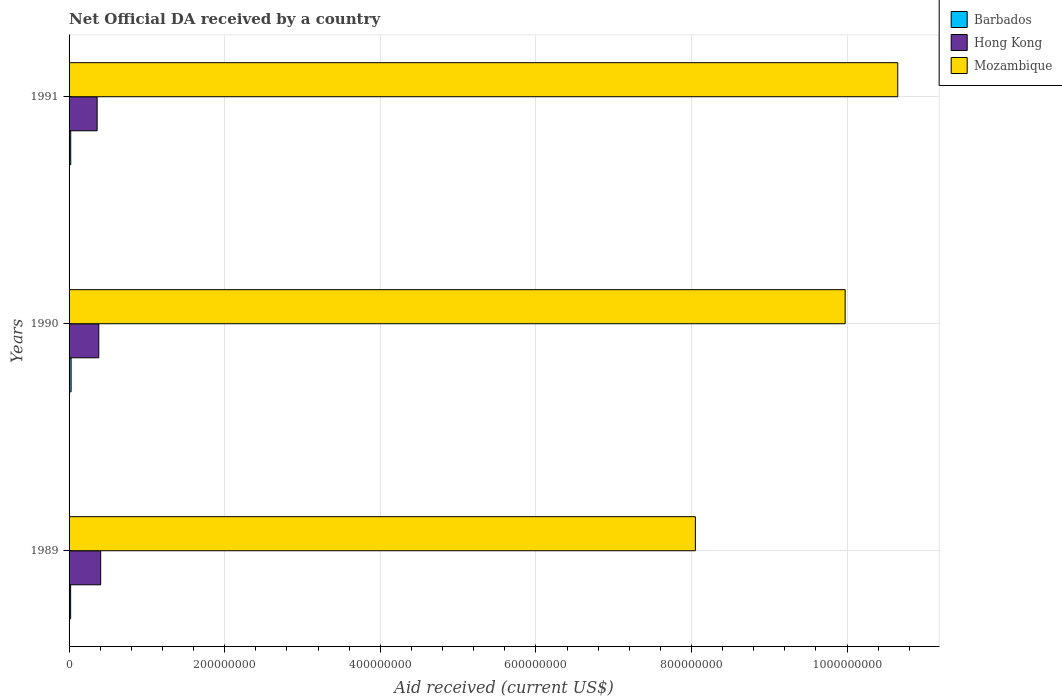Are the number of bars per tick equal to the number of legend labels?
Give a very brief answer. Yes. Are the number of bars on each tick of the Y-axis equal?
Offer a terse response. Yes. How many bars are there on the 1st tick from the top?
Your answer should be compact. 3. In how many cases, is the number of bars for a given year not equal to the number of legend labels?
Ensure brevity in your answer.  0. What is the net official development assistance aid received in Barbados in 1991?
Offer a terse response. 2.12e+06. Across all years, what is the maximum net official development assistance aid received in Mozambique?
Provide a succinct answer. 1.07e+09. Across all years, what is the minimum net official development assistance aid received in Barbados?
Ensure brevity in your answer.  2.01e+06. In which year was the net official development assistance aid received in Mozambique maximum?
Provide a succinct answer. 1991. In which year was the net official development assistance aid received in Hong Kong minimum?
Make the answer very short. 1991. What is the total net official development assistance aid received in Hong Kong in the graph?
Keep it short and to the point. 1.15e+08. What is the difference between the net official development assistance aid received in Mozambique in 1989 and that in 1990?
Your answer should be very brief. -1.93e+08. What is the difference between the net official development assistance aid received in Hong Kong in 1990 and the net official development assistance aid received in Barbados in 1989?
Provide a short and direct response. 3.62e+07. What is the average net official development assistance aid received in Mozambique per year?
Your response must be concise. 9.56e+08. In the year 1991, what is the difference between the net official development assistance aid received in Barbados and net official development assistance aid received in Mozambique?
Make the answer very short. -1.06e+09. In how many years, is the net official development assistance aid received in Mozambique greater than 640000000 US$?
Your answer should be very brief. 3. What is the ratio of the net official development assistance aid received in Barbados in 1989 to that in 1991?
Offer a very short reply. 0.95. Is the net official development assistance aid received in Barbados in 1989 less than that in 1990?
Offer a terse response. Yes. Is the difference between the net official development assistance aid received in Barbados in 1989 and 1990 greater than the difference between the net official development assistance aid received in Mozambique in 1989 and 1990?
Provide a succinct answer. Yes. What is the difference between the highest and the second highest net official development assistance aid received in Barbados?
Offer a very short reply. 5.10e+05. What is the difference between the highest and the lowest net official development assistance aid received in Hong Kong?
Your answer should be compact. 4.55e+06. Is the sum of the net official development assistance aid received in Barbados in 1990 and 1991 greater than the maximum net official development assistance aid received in Hong Kong across all years?
Your answer should be very brief. No. What does the 3rd bar from the top in 1989 represents?
Ensure brevity in your answer.  Barbados. What does the 1st bar from the bottom in 1991 represents?
Provide a short and direct response. Barbados. Is it the case that in every year, the sum of the net official development assistance aid received in Barbados and net official development assistance aid received in Mozambique is greater than the net official development assistance aid received in Hong Kong?
Your answer should be very brief. Yes. How many bars are there?
Your answer should be compact. 9. Are all the bars in the graph horizontal?
Make the answer very short. Yes. Are the values on the major ticks of X-axis written in scientific E-notation?
Offer a very short reply. No. Does the graph contain any zero values?
Ensure brevity in your answer.  No. How many legend labels are there?
Offer a very short reply. 3. How are the legend labels stacked?
Ensure brevity in your answer.  Vertical. What is the title of the graph?
Give a very brief answer. Net Official DA received by a country. Does "Benin" appear as one of the legend labels in the graph?
Make the answer very short. No. What is the label or title of the X-axis?
Your response must be concise. Aid received (current US$). What is the Aid received (current US$) of Barbados in 1989?
Provide a short and direct response. 2.01e+06. What is the Aid received (current US$) in Hong Kong in 1989?
Keep it short and to the point. 4.06e+07. What is the Aid received (current US$) in Mozambique in 1989?
Make the answer very short. 8.05e+08. What is the Aid received (current US$) in Barbados in 1990?
Your answer should be compact. 2.63e+06. What is the Aid received (current US$) of Hong Kong in 1990?
Provide a succinct answer. 3.82e+07. What is the Aid received (current US$) in Mozambique in 1990?
Offer a very short reply. 9.98e+08. What is the Aid received (current US$) of Barbados in 1991?
Your answer should be compact. 2.12e+06. What is the Aid received (current US$) of Hong Kong in 1991?
Offer a terse response. 3.61e+07. What is the Aid received (current US$) in Mozambique in 1991?
Keep it short and to the point. 1.07e+09. Across all years, what is the maximum Aid received (current US$) in Barbados?
Provide a short and direct response. 2.63e+06. Across all years, what is the maximum Aid received (current US$) of Hong Kong?
Your response must be concise. 4.06e+07. Across all years, what is the maximum Aid received (current US$) in Mozambique?
Your answer should be very brief. 1.07e+09. Across all years, what is the minimum Aid received (current US$) of Barbados?
Offer a very short reply. 2.01e+06. Across all years, what is the minimum Aid received (current US$) in Hong Kong?
Give a very brief answer. 3.61e+07. Across all years, what is the minimum Aid received (current US$) in Mozambique?
Ensure brevity in your answer.  8.05e+08. What is the total Aid received (current US$) in Barbados in the graph?
Offer a very short reply. 6.76e+06. What is the total Aid received (current US$) in Hong Kong in the graph?
Offer a very short reply. 1.15e+08. What is the total Aid received (current US$) of Mozambique in the graph?
Make the answer very short. 2.87e+09. What is the difference between the Aid received (current US$) in Barbados in 1989 and that in 1990?
Give a very brief answer. -6.20e+05. What is the difference between the Aid received (current US$) of Hong Kong in 1989 and that in 1990?
Make the answer very short. 2.46e+06. What is the difference between the Aid received (current US$) in Mozambique in 1989 and that in 1990?
Keep it short and to the point. -1.93e+08. What is the difference between the Aid received (current US$) of Hong Kong in 1989 and that in 1991?
Ensure brevity in your answer.  4.55e+06. What is the difference between the Aid received (current US$) in Mozambique in 1989 and that in 1991?
Provide a short and direct response. -2.60e+08. What is the difference between the Aid received (current US$) of Barbados in 1990 and that in 1991?
Make the answer very short. 5.10e+05. What is the difference between the Aid received (current US$) of Hong Kong in 1990 and that in 1991?
Offer a very short reply. 2.09e+06. What is the difference between the Aid received (current US$) in Mozambique in 1990 and that in 1991?
Make the answer very short. -6.76e+07. What is the difference between the Aid received (current US$) of Barbados in 1989 and the Aid received (current US$) of Hong Kong in 1990?
Your answer should be compact. -3.62e+07. What is the difference between the Aid received (current US$) in Barbados in 1989 and the Aid received (current US$) in Mozambique in 1990?
Provide a succinct answer. -9.96e+08. What is the difference between the Aid received (current US$) of Hong Kong in 1989 and the Aid received (current US$) of Mozambique in 1990?
Your answer should be compact. -9.57e+08. What is the difference between the Aid received (current US$) of Barbados in 1989 and the Aid received (current US$) of Hong Kong in 1991?
Your response must be concise. -3.41e+07. What is the difference between the Aid received (current US$) in Barbados in 1989 and the Aid received (current US$) in Mozambique in 1991?
Provide a succinct answer. -1.06e+09. What is the difference between the Aid received (current US$) of Hong Kong in 1989 and the Aid received (current US$) of Mozambique in 1991?
Keep it short and to the point. -1.02e+09. What is the difference between the Aid received (current US$) of Barbados in 1990 and the Aid received (current US$) of Hong Kong in 1991?
Keep it short and to the point. -3.34e+07. What is the difference between the Aid received (current US$) in Barbados in 1990 and the Aid received (current US$) in Mozambique in 1991?
Your answer should be very brief. -1.06e+09. What is the difference between the Aid received (current US$) of Hong Kong in 1990 and the Aid received (current US$) of Mozambique in 1991?
Offer a very short reply. -1.03e+09. What is the average Aid received (current US$) in Barbados per year?
Offer a terse response. 2.25e+06. What is the average Aid received (current US$) in Hong Kong per year?
Your answer should be very brief. 3.83e+07. What is the average Aid received (current US$) of Mozambique per year?
Offer a very short reply. 9.56e+08. In the year 1989, what is the difference between the Aid received (current US$) in Barbados and Aid received (current US$) in Hong Kong?
Your response must be concise. -3.86e+07. In the year 1989, what is the difference between the Aid received (current US$) in Barbados and Aid received (current US$) in Mozambique?
Your answer should be very brief. -8.03e+08. In the year 1989, what is the difference between the Aid received (current US$) of Hong Kong and Aid received (current US$) of Mozambique?
Keep it short and to the point. -7.64e+08. In the year 1990, what is the difference between the Aid received (current US$) of Barbados and Aid received (current US$) of Hong Kong?
Ensure brevity in your answer.  -3.55e+07. In the year 1990, what is the difference between the Aid received (current US$) of Barbados and Aid received (current US$) of Mozambique?
Make the answer very short. -9.95e+08. In the year 1990, what is the difference between the Aid received (current US$) in Hong Kong and Aid received (current US$) in Mozambique?
Provide a short and direct response. -9.59e+08. In the year 1991, what is the difference between the Aid received (current US$) in Barbados and Aid received (current US$) in Hong Kong?
Make the answer very short. -3.40e+07. In the year 1991, what is the difference between the Aid received (current US$) in Barbados and Aid received (current US$) in Mozambique?
Give a very brief answer. -1.06e+09. In the year 1991, what is the difference between the Aid received (current US$) of Hong Kong and Aid received (current US$) of Mozambique?
Make the answer very short. -1.03e+09. What is the ratio of the Aid received (current US$) of Barbados in 1989 to that in 1990?
Give a very brief answer. 0.76. What is the ratio of the Aid received (current US$) in Hong Kong in 1989 to that in 1990?
Provide a succinct answer. 1.06. What is the ratio of the Aid received (current US$) in Mozambique in 1989 to that in 1990?
Your answer should be very brief. 0.81. What is the ratio of the Aid received (current US$) of Barbados in 1989 to that in 1991?
Ensure brevity in your answer.  0.95. What is the ratio of the Aid received (current US$) in Hong Kong in 1989 to that in 1991?
Offer a terse response. 1.13. What is the ratio of the Aid received (current US$) in Mozambique in 1989 to that in 1991?
Your response must be concise. 0.76. What is the ratio of the Aid received (current US$) in Barbados in 1990 to that in 1991?
Provide a short and direct response. 1.24. What is the ratio of the Aid received (current US$) of Hong Kong in 1990 to that in 1991?
Give a very brief answer. 1.06. What is the ratio of the Aid received (current US$) in Mozambique in 1990 to that in 1991?
Give a very brief answer. 0.94. What is the difference between the highest and the second highest Aid received (current US$) of Barbados?
Offer a very short reply. 5.10e+05. What is the difference between the highest and the second highest Aid received (current US$) in Hong Kong?
Offer a terse response. 2.46e+06. What is the difference between the highest and the second highest Aid received (current US$) in Mozambique?
Your answer should be compact. 6.76e+07. What is the difference between the highest and the lowest Aid received (current US$) in Barbados?
Give a very brief answer. 6.20e+05. What is the difference between the highest and the lowest Aid received (current US$) of Hong Kong?
Your response must be concise. 4.55e+06. What is the difference between the highest and the lowest Aid received (current US$) of Mozambique?
Keep it short and to the point. 2.60e+08. 